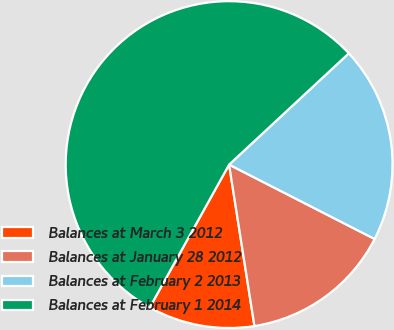Convert chart. <chart><loc_0><loc_0><loc_500><loc_500><pie_chart><fcel>Balances at March 3 2012<fcel>Balances at January 28 2012<fcel>Balances at February 2 2013<fcel>Balances at February 1 2014<nl><fcel>10.55%<fcel>15.0%<fcel>19.44%<fcel>55.01%<nl></chart> 